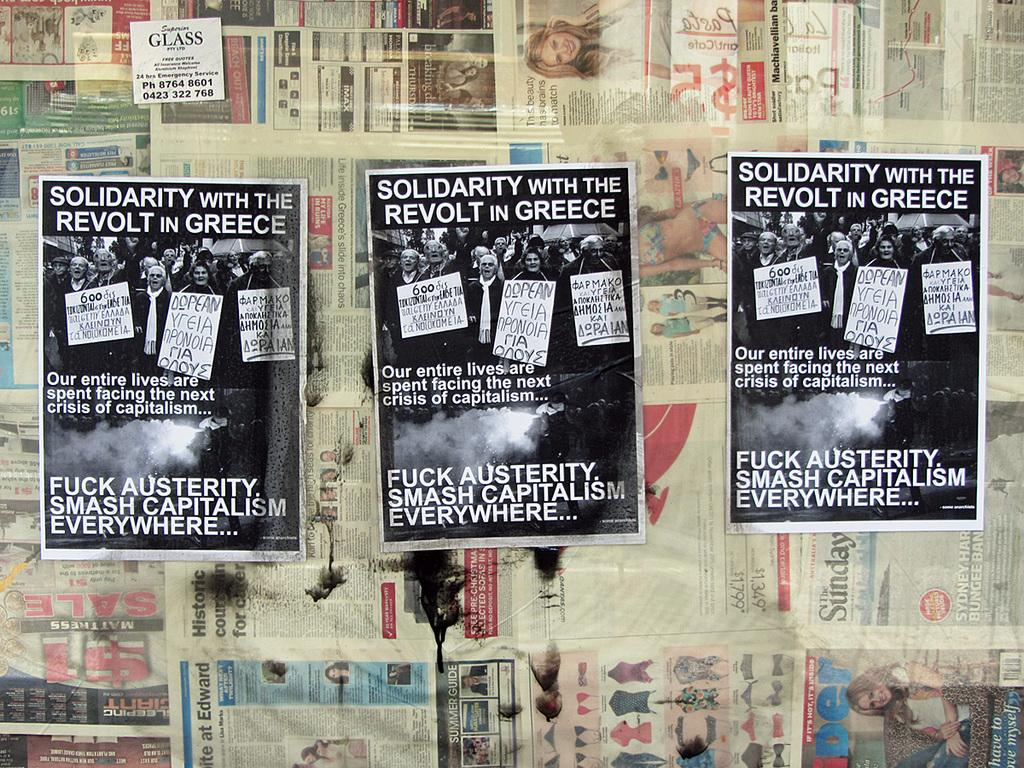<image>
Provide a brief description of the given image. Three posters on a wall saying "Solidarity with the Revolt in Greece". 